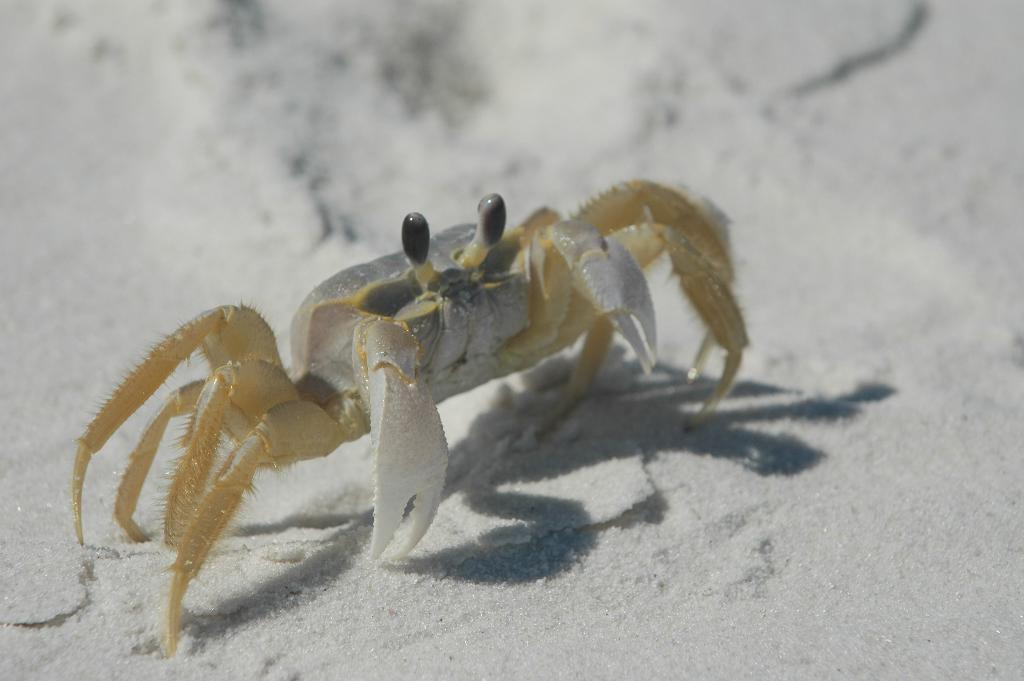What animal can be seen in the image? There is a crab in the image. What is the crab doing in the image? The crab is crawling in the sand. What type of soap is the crab using to clean itself in the image? There is no soap present in the image, and crabs do not use soap to clean themselves. 